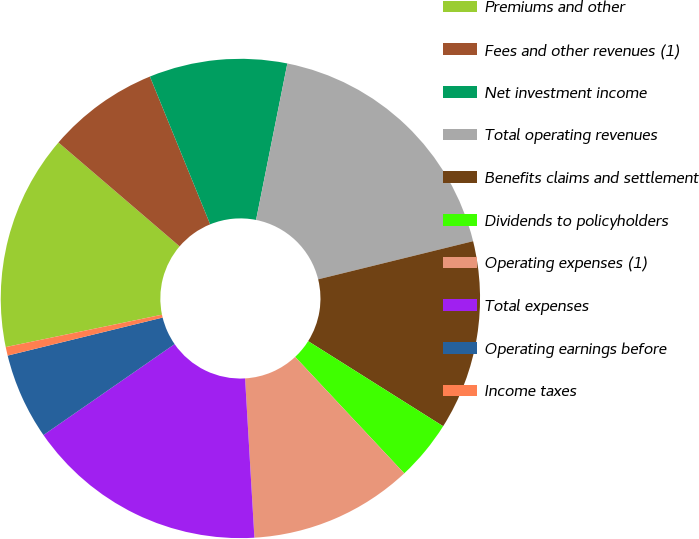Convert chart to OTSL. <chart><loc_0><loc_0><loc_500><loc_500><pie_chart><fcel>Premiums and other<fcel>Fees and other revenues (1)<fcel>Net investment income<fcel>Total operating revenues<fcel>Benefits claims and settlement<fcel>Dividends to policyholders<fcel>Operating expenses (1)<fcel>Total expenses<fcel>Operating earnings before<fcel>Income taxes<nl><fcel>14.53%<fcel>7.56%<fcel>9.3%<fcel>18.02%<fcel>12.79%<fcel>4.07%<fcel>11.05%<fcel>16.28%<fcel>5.82%<fcel>0.58%<nl></chart> 